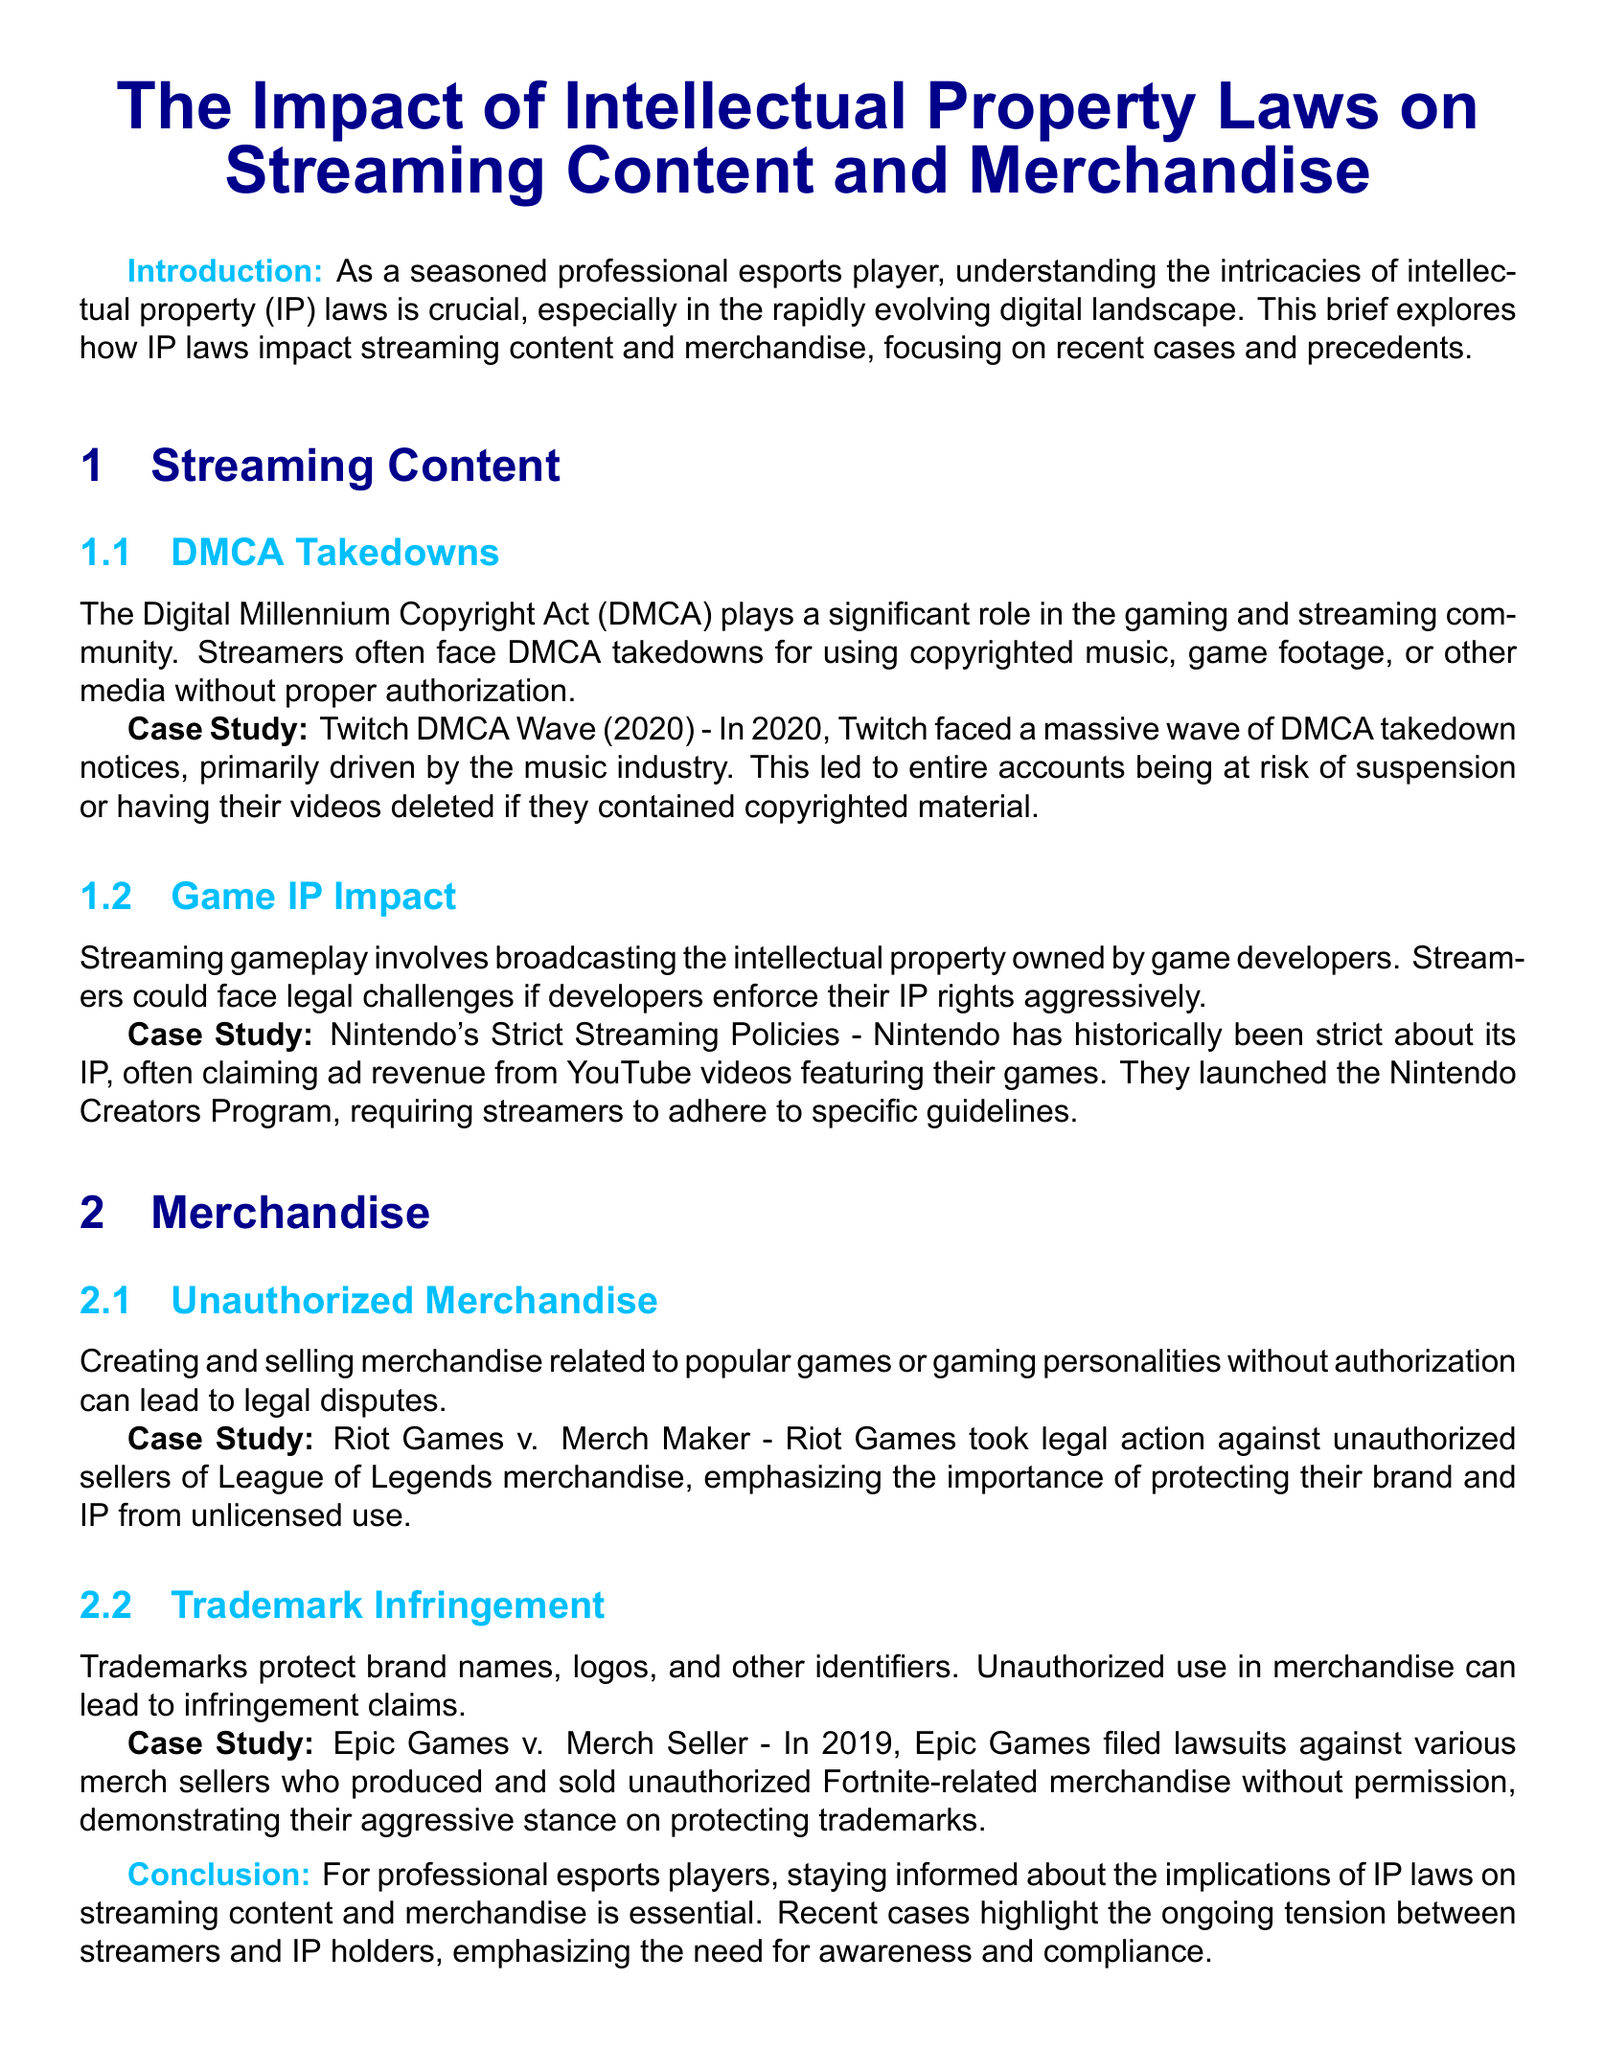What is the title of the document? The title is stated at the center of the document.
Answer: The Impact of Intellectual Property Laws on Streaming Content and Merchandise What legislation is highlighted in relation to streaming content? The document mentions a specific act relevant to streaming issues.
Answer: DMCA What year did Twitch face a massive wave of DMCA takedown notices? The document specifies a particular year for this event.
Answer: 2020 Which company launched the Nintendo Creators Program? The document names a specific company associated with streaming policies.
Answer: Nintendo What legal action did Riot Games pursue against unauthorized sellers? The case mentioned involves a legal dispute regarding merchandise.
Answer: Riot Games v. Merch Maker In what year did Epic Games file lawsuits against unauthorized merchandise sellers? The document provides a specific year for this legal action.
Answer: 2019 What is the focus of the introduction? The introduction outlines the main theme of the document.
Answer: Intellectual property (IP) laws What is emphasized as essential for professional esports players? The conclusion indicates what knowledge is important for the target audience.
Answer: Awareness and compliance What type of infringement is discussed in relation to trademarks? The document categorizes a specific legal issue related to brand identifiers.
Answer: Trademark infringement What is one example of a significant case related to unauthorized merchandise? The document cites a specific case involving merchandise disputes.
Answer: Riot Games v. Merch Maker 